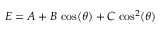Convert formula to latex. <formula><loc_0><loc_0><loc_500><loc_500>E = A + B \, \cos ( \theta ) + C \, \cos ^ { 2 } ( \theta )</formula> 